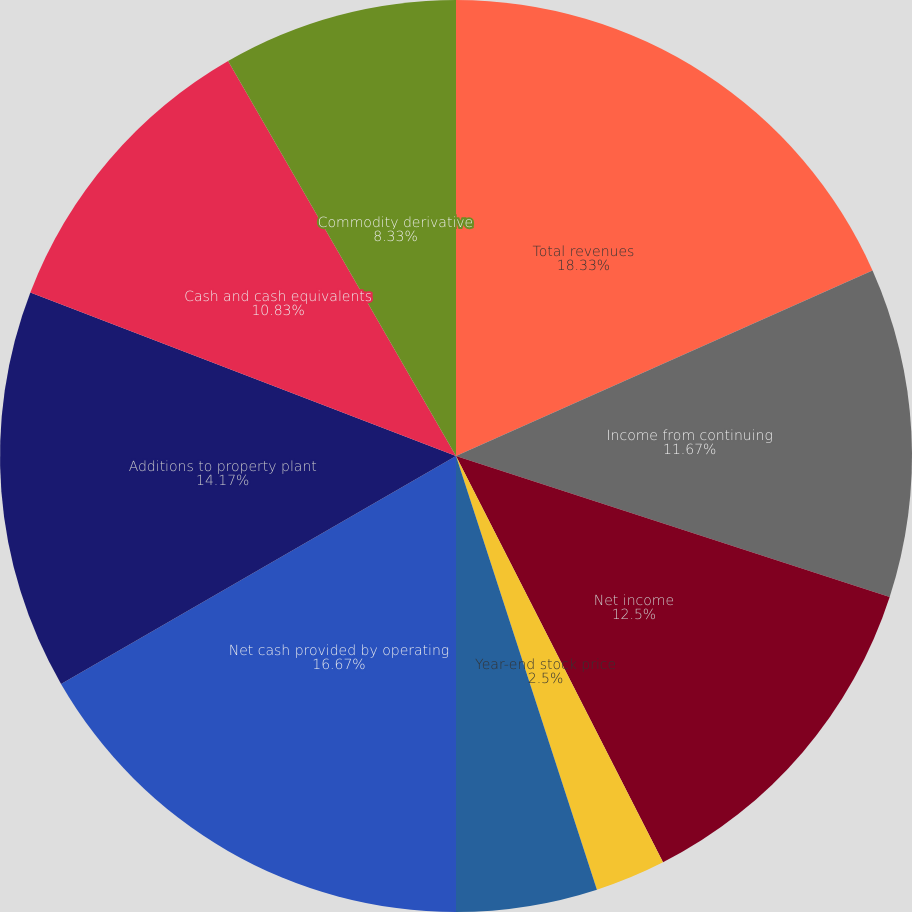Convert chart. <chart><loc_0><loc_0><loc_500><loc_500><pie_chart><fcel>Total revenues<fcel>Income from continuing<fcel>Net income<fcel>Cash dividends<fcel>Year-end stock price<fcel>Basic weighted average shares<fcel>Net cash provided by operating<fcel>Additions to property plant<fcel>Cash and cash equivalents<fcel>Commodity derivative<nl><fcel>18.33%<fcel>11.67%<fcel>12.5%<fcel>0.0%<fcel>2.5%<fcel>5.0%<fcel>16.67%<fcel>14.17%<fcel>10.83%<fcel>8.33%<nl></chart> 